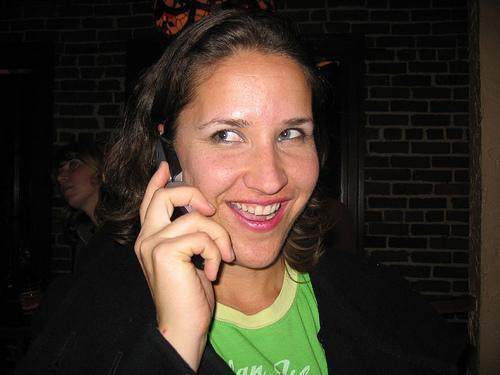Which hand is she using to hold the phone?
Select the accurate answer and provide explanation: 'Answer: answer
Rationale: rationale.'
Options: Left, both, right, neither. Answer: right.
Rationale: It is on that side of her body 